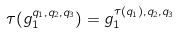Convert formula to latex. <formula><loc_0><loc_0><loc_500><loc_500>\tau ( g _ { 1 } ^ { q _ { 1 } , q _ { 2 } , q _ { 3 } } ) = g _ { 1 } ^ { \tau ( q _ { 1 } ) , q _ { 2 } , q _ { 3 } }</formula> 